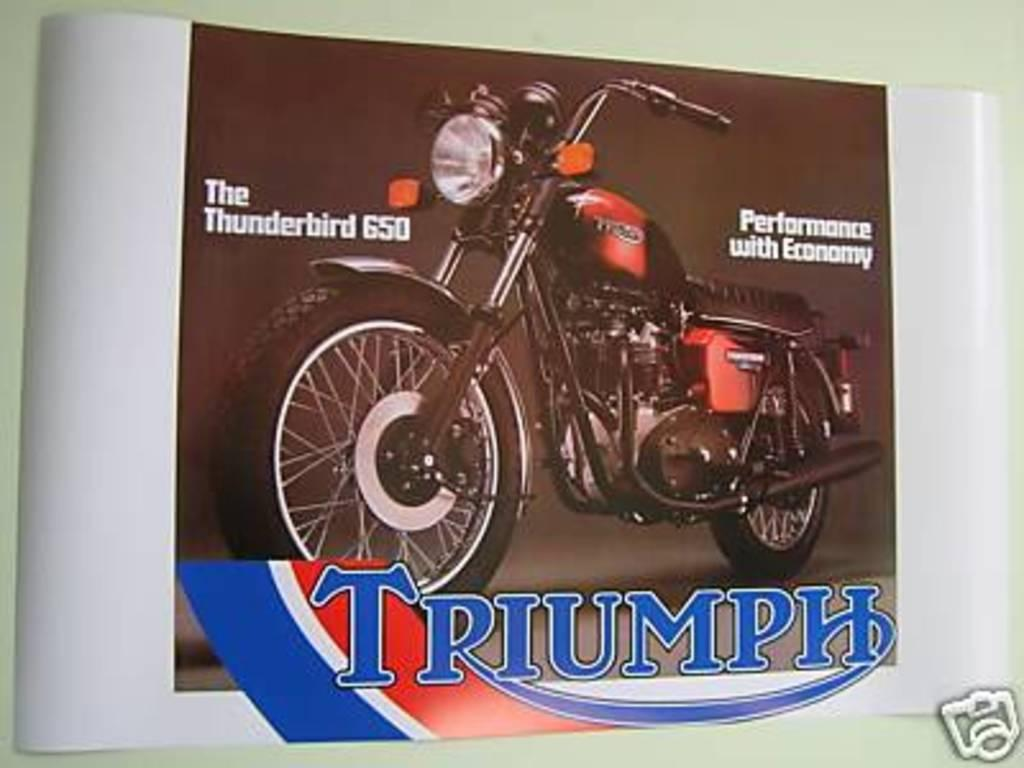What is present on the wall in the image? There is a poster in the image. How is the poster attached to the wall? The poster is attached to the wall. What is depicted on the poster? The poster contains an image of a red bike. Are there any words on the poster? Yes, text is present on the poster. What type of linen is used to cover the red bike in the image? There is no linen present in the image, and the red bike is depicted on the poster, not in real life. 